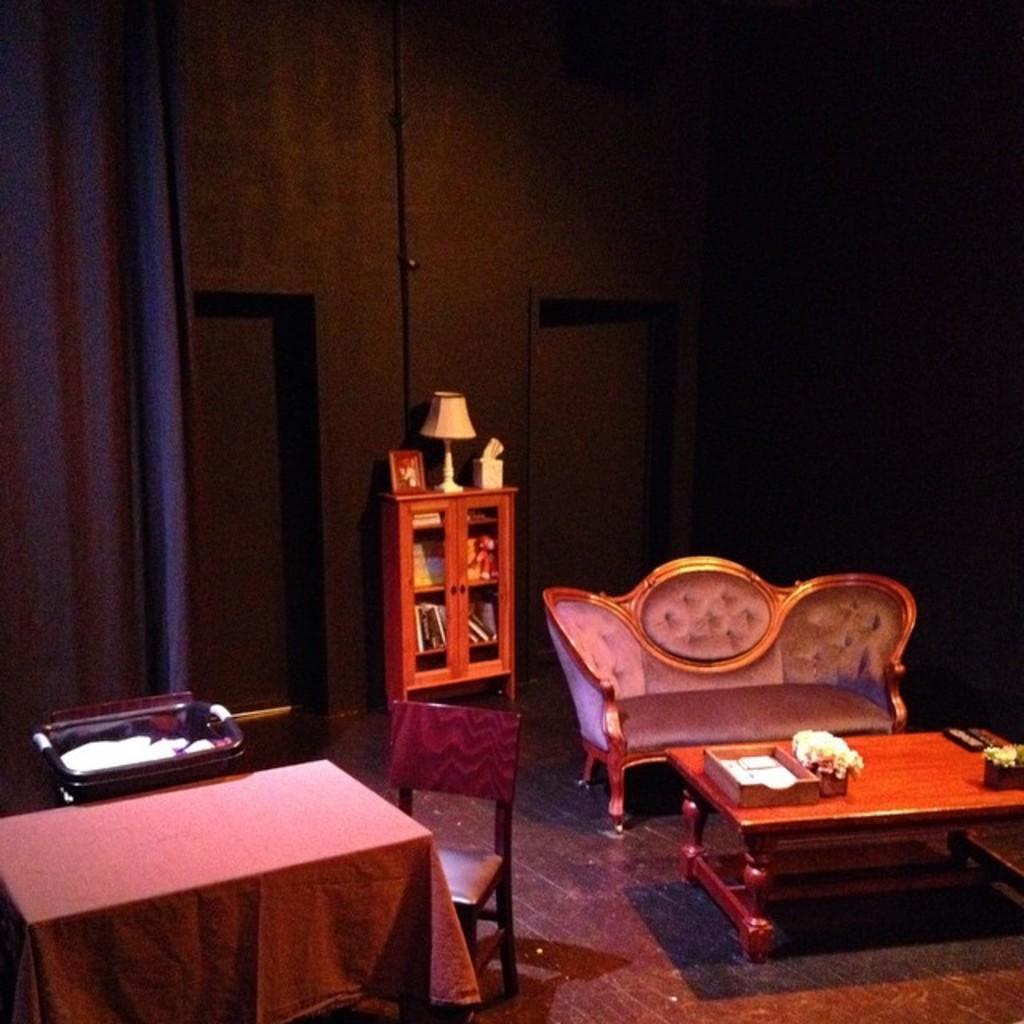Describe this image in one or two sentences. In this image we can see a sofa, chairs, table, cupboard, lamp and curtains. 